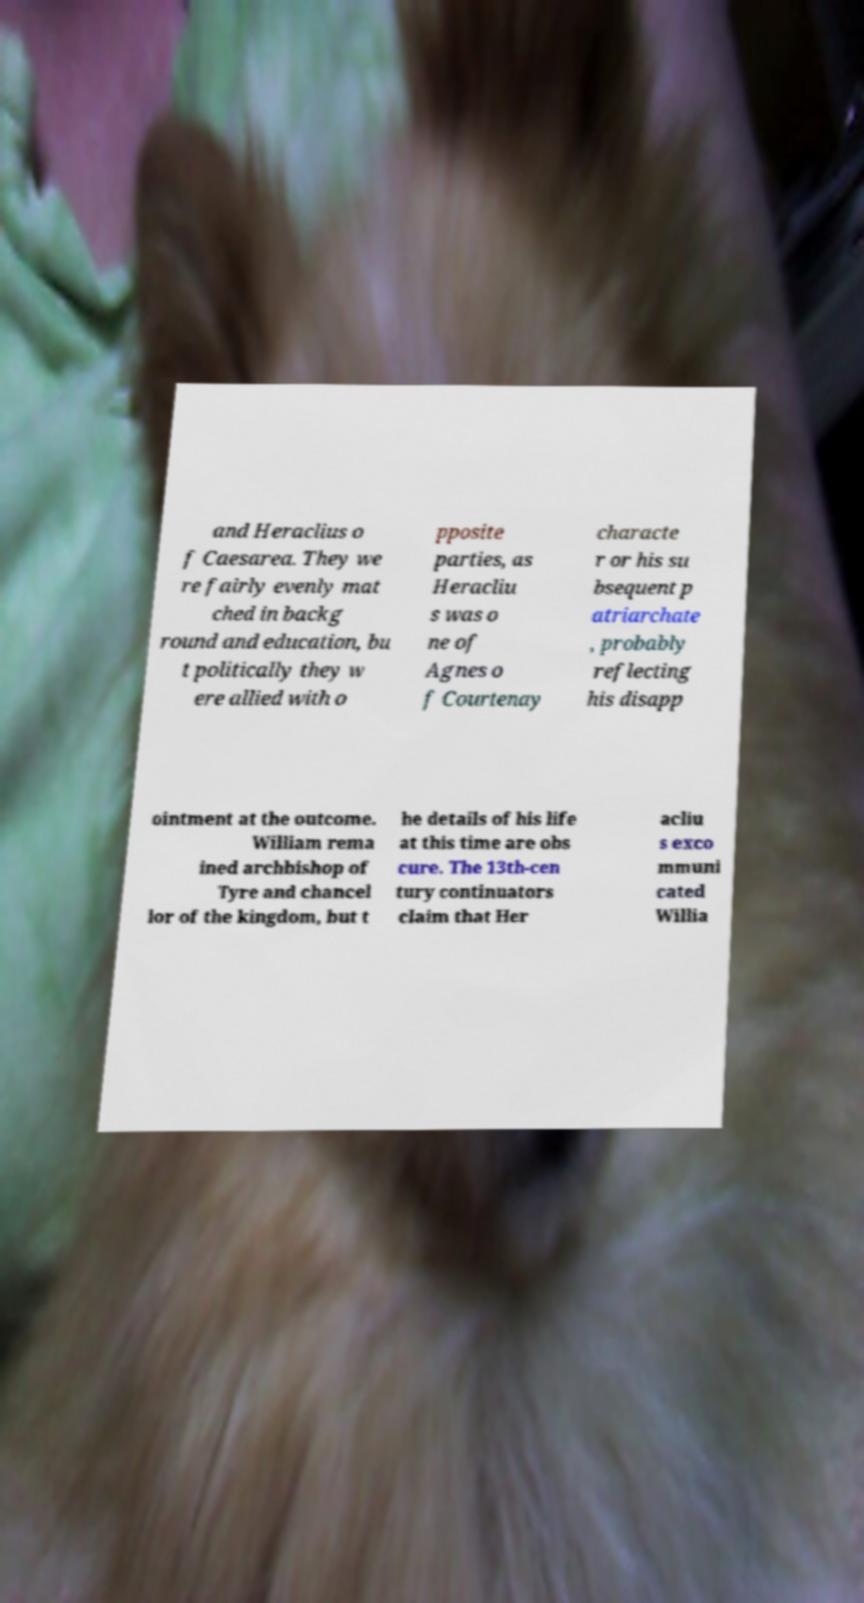For documentation purposes, I need the text within this image transcribed. Could you provide that? and Heraclius o f Caesarea. They we re fairly evenly mat ched in backg round and education, bu t politically they w ere allied with o pposite parties, as Heracliu s was o ne of Agnes o f Courtenay characte r or his su bsequent p atriarchate , probably reflecting his disapp ointment at the outcome. William rema ined archbishop of Tyre and chancel lor of the kingdom, but t he details of his life at this time are obs cure. The 13th-cen tury continuators claim that Her acliu s exco mmuni cated Willia 